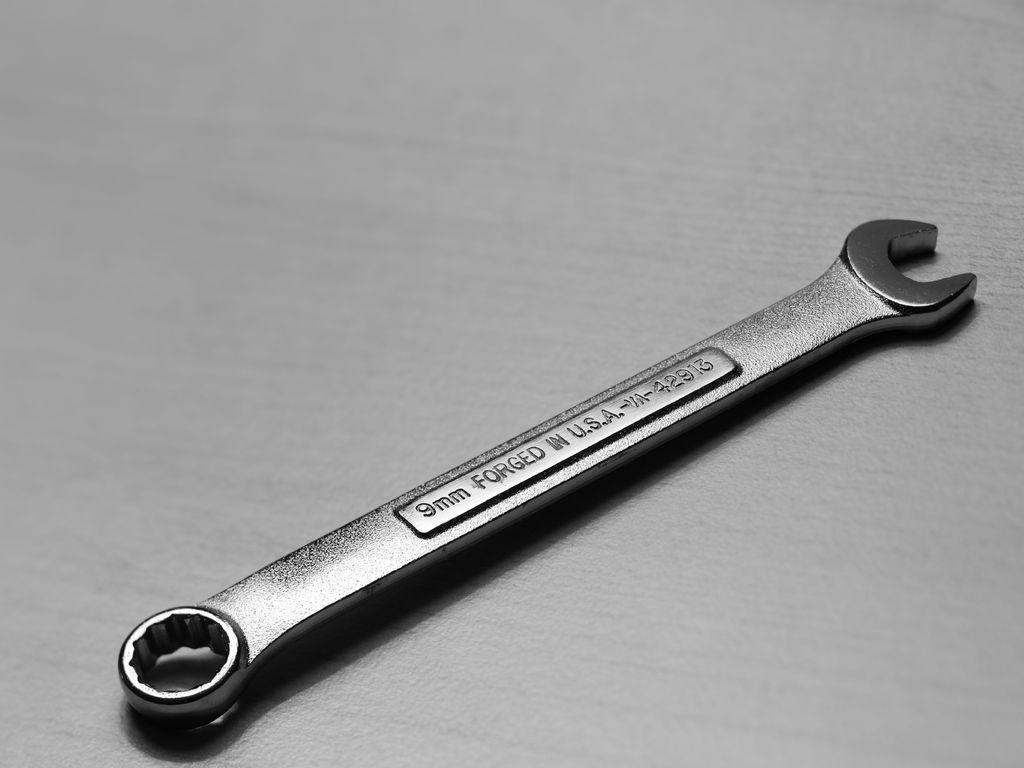Could you give a brief overview of what you see in this image? In this image we can see spanner which is of 9mm. 